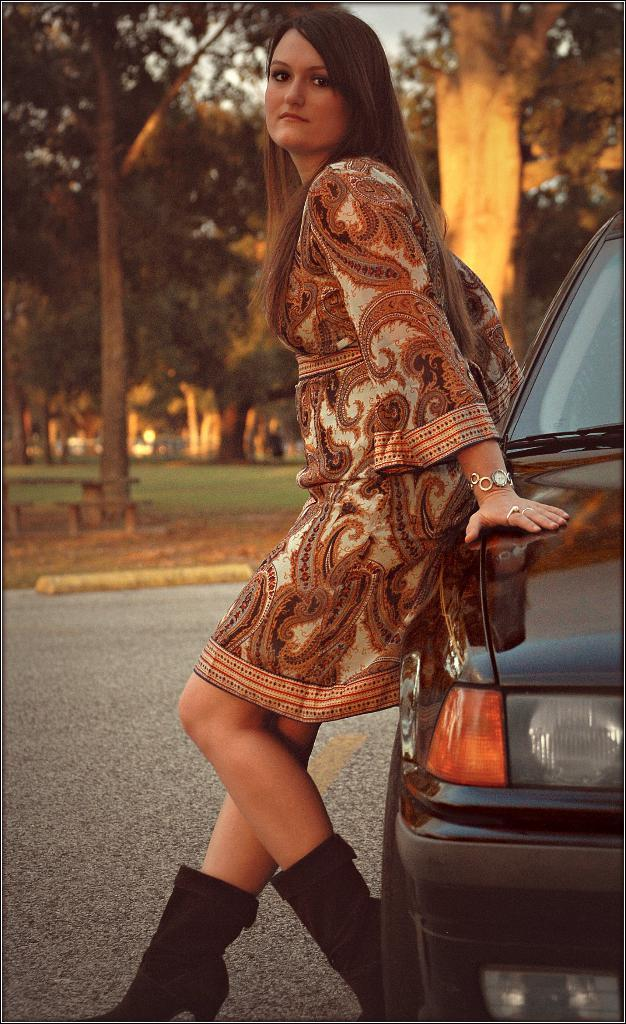What type of vehicle is in the image? There is a black color car in the image. Who is present in the image besides the car? There is a woman standing in the image. What can be seen in the background of the image? There is grass and trees in the background of the image. Where is the faucet located in the image? There is no faucet present in the image. How many friends are visible in the image? There is no mention of friends in the image; only a woman is present. 